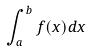<formula> <loc_0><loc_0><loc_500><loc_500>\int _ { a } ^ { b } f ( x ) d x</formula> 